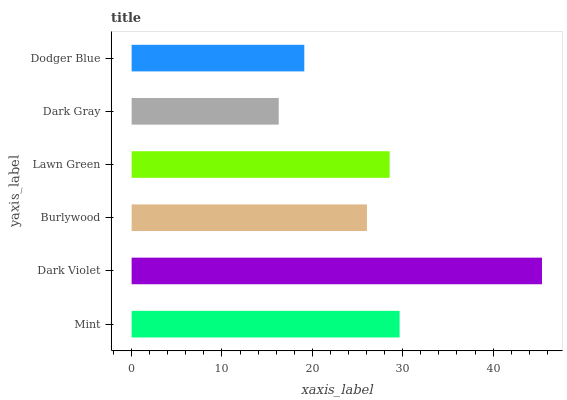Is Dark Gray the minimum?
Answer yes or no. Yes. Is Dark Violet the maximum?
Answer yes or no. Yes. Is Burlywood the minimum?
Answer yes or no. No. Is Burlywood the maximum?
Answer yes or no. No. Is Dark Violet greater than Burlywood?
Answer yes or no. Yes. Is Burlywood less than Dark Violet?
Answer yes or no. Yes. Is Burlywood greater than Dark Violet?
Answer yes or no. No. Is Dark Violet less than Burlywood?
Answer yes or no. No. Is Lawn Green the high median?
Answer yes or no. Yes. Is Burlywood the low median?
Answer yes or no. Yes. Is Dark Violet the high median?
Answer yes or no. No. Is Dark Violet the low median?
Answer yes or no. No. 